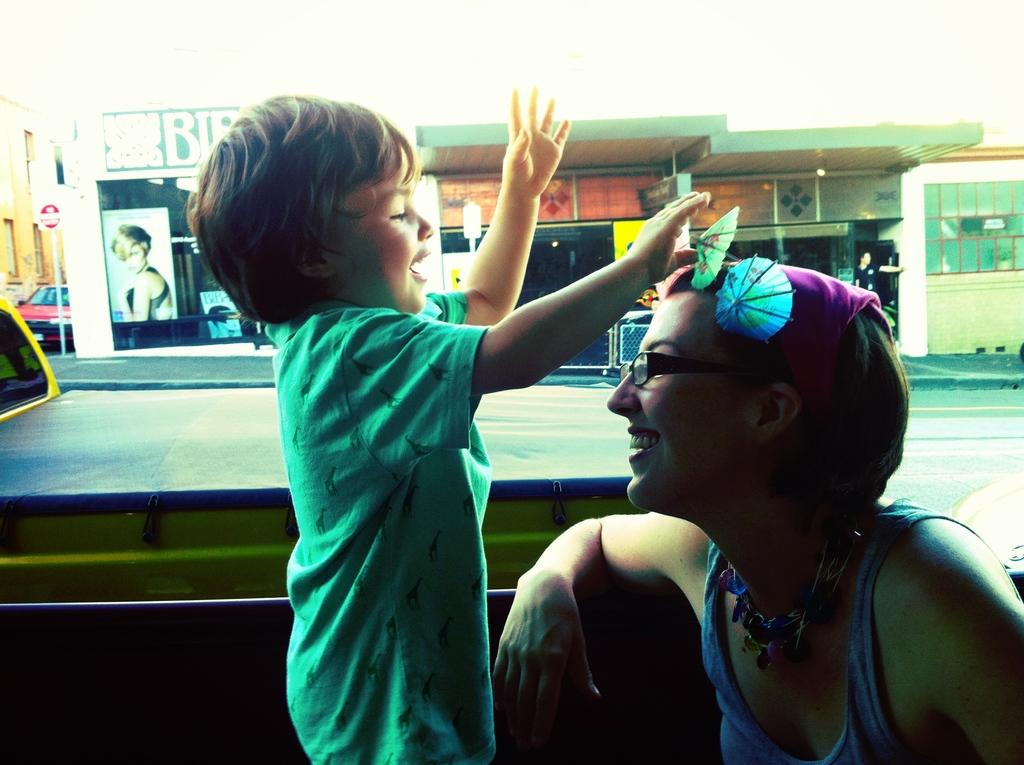Who is present in the image? There is a woman and a kid in the image. What can be seen in the background of the image? There are stores, a road, and name boards visible in the background of the image. What flavor of toothbrush is the woman using in the image? There is no toothbrush present in the image, so it is not possible to determine the flavor of any toothbrush. 